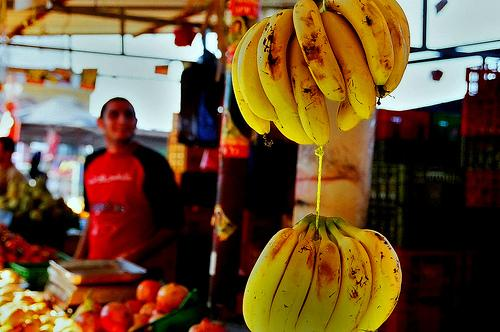What can hanging the bananas avoid?

Choices:
A) being damaged
B) black spots
C) being touched
D) being stolen black spots 